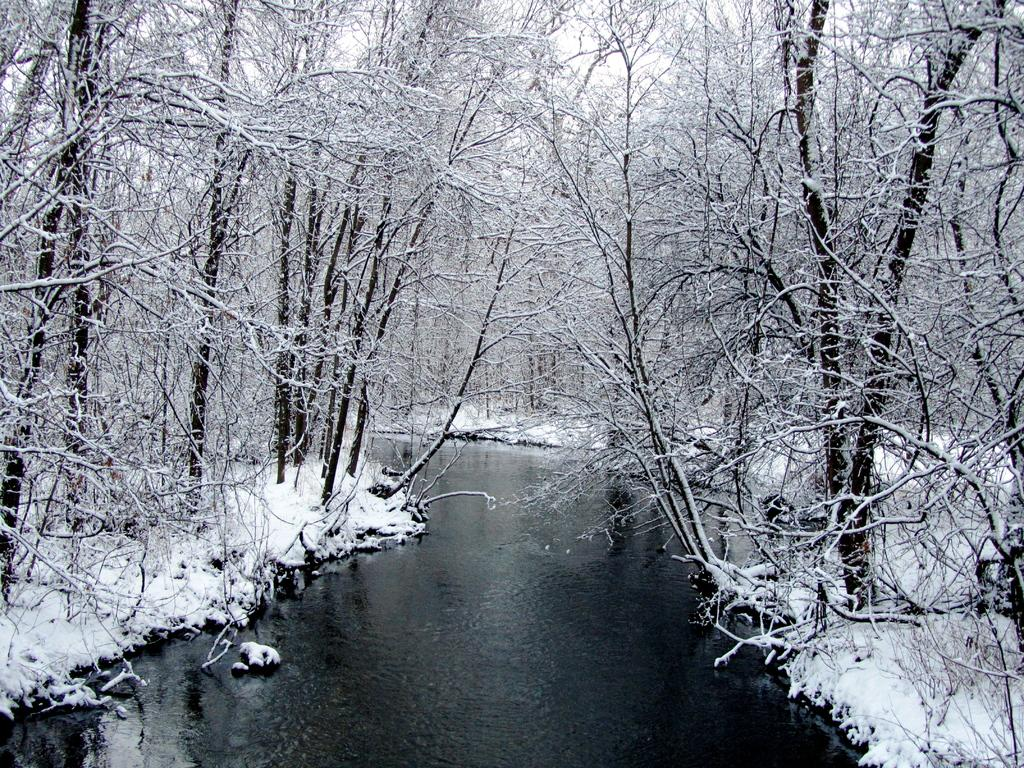What is one of the natural elements visible in the image? Water is visible in the image. What type of precipitation can be seen in the image? There is snow in the image. What can be seen in the background of the image? There are trees in the background of the image. What type of wood is the queen using to build her castle in the image? There is no queen or castle present in the image, and therefore no wood or construction activity can be observed. 